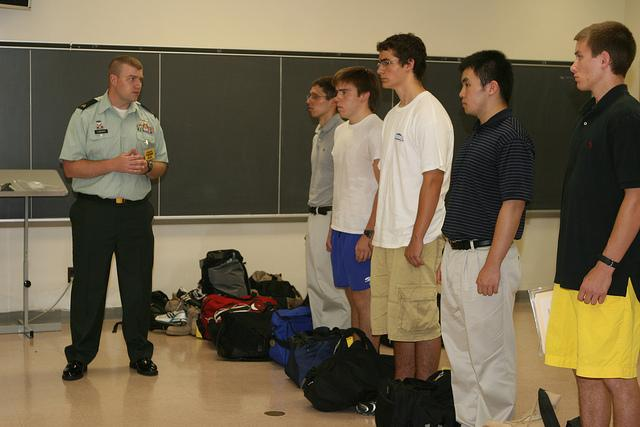What role are persons out of uniform here in? Please explain your reasoning. recruits. The role is a recruit. 